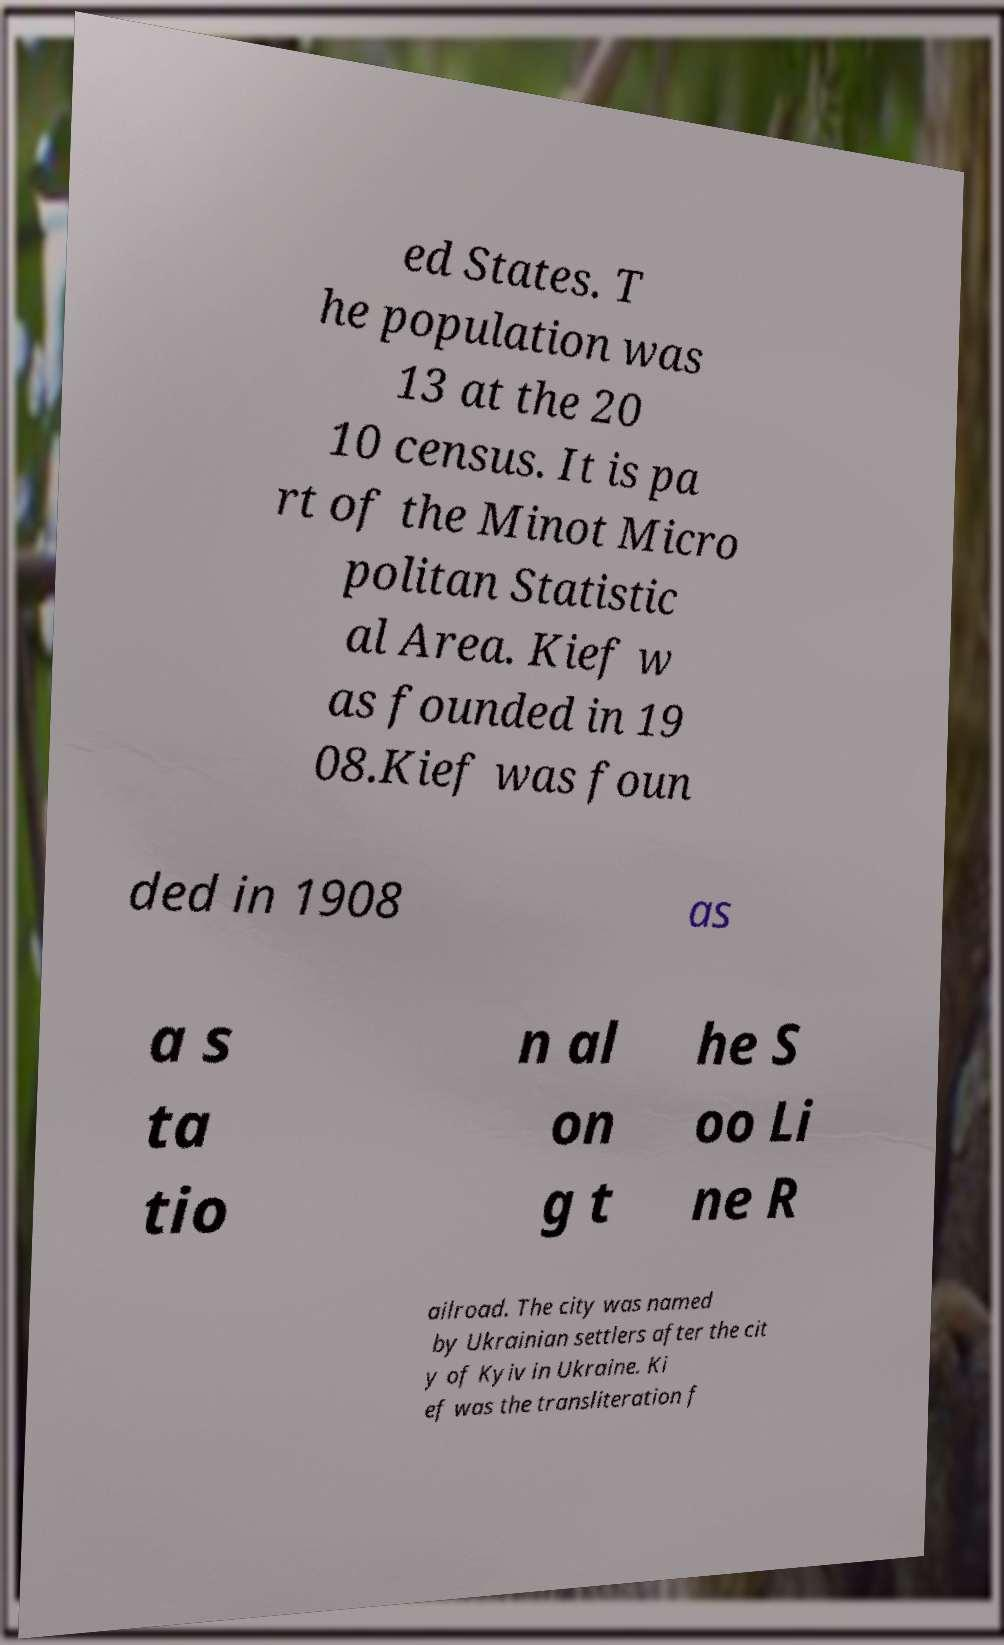For documentation purposes, I need the text within this image transcribed. Could you provide that? ed States. T he population was 13 at the 20 10 census. It is pa rt of the Minot Micro politan Statistic al Area. Kief w as founded in 19 08.Kief was foun ded in 1908 as a s ta tio n al on g t he S oo Li ne R ailroad. The city was named by Ukrainian settlers after the cit y of Kyiv in Ukraine. Ki ef was the transliteration f 